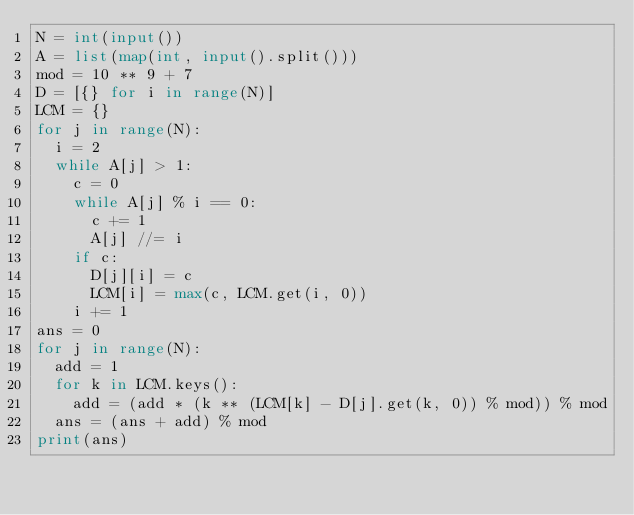<code> <loc_0><loc_0><loc_500><loc_500><_Python_>N = int(input())
A = list(map(int, input().split()))
mod = 10 ** 9 + 7
D = [{} for i in range(N)]
LCM = {}
for j in range(N):
  i = 2
  while A[j] > 1:
    c = 0
    while A[j] % i == 0:
      c += 1
      A[j] //= i
    if c:
      D[j][i] = c
      LCM[i] = max(c, LCM.get(i, 0))
    i += 1
ans = 0
for j in range(N):
  add = 1
  for k in LCM.keys():
    add = (add * (k ** (LCM[k] - D[j].get(k, 0)) % mod)) % mod
  ans = (ans + add) % mod
print(ans)</code> 